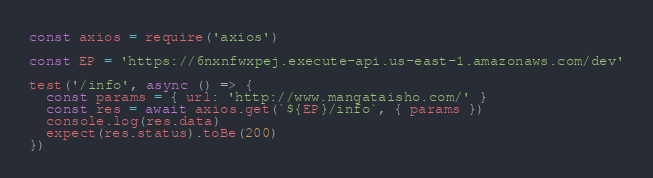Convert code to text. <code><loc_0><loc_0><loc_500><loc_500><_JavaScript_>const axios = require('axios')

const EP = 'https://6nxnfwxpej.execute-api.us-east-1.amazonaws.com/dev'

test('/info', async () => {
  const params = { url: 'http://www.mangataisho.com/' }
  const res = await axios.get(`${EP}/info`, { params })
  console.log(res.data)
  expect(res.status).toBe(200)
})
</code> 